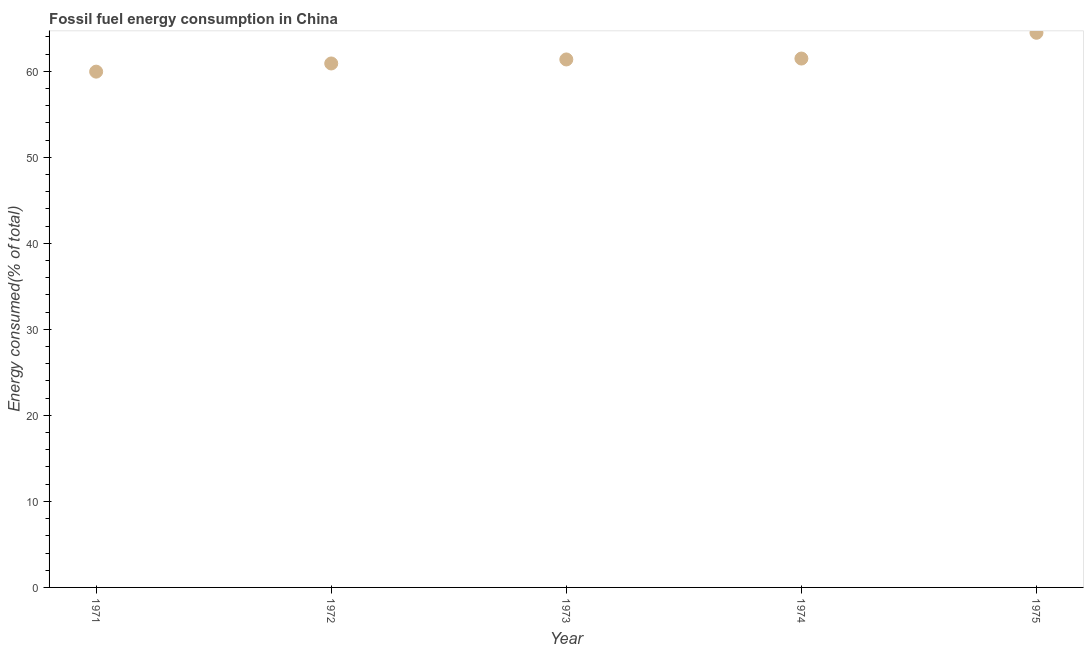What is the fossil fuel energy consumption in 1974?
Ensure brevity in your answer.  61.47. Across all years, what is the maximum fossil fuel energy consumption?
Your answer should be very brief. 64.47. Across all years, what is the minimum fossil fuel energy consumption?
Keep it short and to the point. 59.95. In which year was the fossil fuel energy consumption maximum?
Your answer should be compact. 1975. What is the sum of the fossil fuel energy consumption?
Provide a succinct answer. 308.16. What is the difference between the fossil fuel energy consumption in 1971 and 1973?
Keep it short and to the point. -1.42. What is the average fossil fuel energy consumption per year?
Give a very brief answer. 61.63. What is the median fossil fuel energy consumption?
Provide a short and direct response. 61.37. In how many years, is the fossil fuel energy consumption greater than 26 %?
Provide a short and direct response. 5. What is the ratio of the fossil fuel energy consumption in 1972 to that in 1975?
Give a very brief answer. 0.94. Is the fossil fuel energy consumption in 1971 less than that in 1975?
Make the answer very short. Yes. Is the difference between the fossil fuel energy consumption in 1971 and 1975 greater than the difference between any two years?
Your answer should be compact. Yes. What is the difference between the highest and the second highest fossil fuel energy consumption?
Offer a very short reply. 3. What is the difference between the highest and the lowest fossil fuel energy consumption?
Ensure brevity in your answer.  4.52. In how many years, is the fossil fuel energy consumption greater than the average fossil fuel energy consumption taken over all years?
Your answer should be very brief. 1. Does the fossil fuel energy consumption monotonically increase over the years?
Provide a succinct answer. Yes. How many dotlines are there?
Your response must be concise. 1. What is the title of the graph?
Provide a short and direct response. Fossil fuel energy consumption in China. What is the label or title of the X-axis?
Keep it short and to the point. Year. What is the label or title of the Y-axis?
Your response must be concise. Energy consumed(% of total). What is the Energy consumed(% of total) in 1971?
Offer a very short reply. 59.95. What is the Energy consumed(% of total) in 1972?
Give a very brief answer. 60.9. What is the Energy consumed(% of total) in 1973?
Ensure brevity in your answer.  61.37. What is the Energy consumed(% of total) in 1974?
Provide a short and direct response. 61.47. What is the Energy consumed(% of total) in 1975?
Your answer should be very brief. 64.47. What is the difference between the Energy consumed(% of total) in 1971 and 1972?
Keep it short and to the point. -0.95. What is the difference between the Energy consumed(% of total) in 1971 and 1973?
Your answer should be compact. -1.42. What is the difference between the Energy consumed(% of total) in 1971 and 1974?
Keep it short and to the point. -1.52. What is the difference between the Energy consumed(% of total) in 1971 and 1975?
Your response must be concise. -4.52. What is the difference between the Energy consumed(% of total) in 1972 and 1973?
Make the answer very short. -0.47. What is the difference between the Energy consumed(% of total) in 1972 and 1974?
Offer a terse response. -0.57. What is the difference between the Energy consumed(% of total) in 1972 and 1975?
Your answer should be compact. -3.57. What is the difference between the Energy consumed(% of total) in 1973 and 1974?
Your answer should be very brief. -0.11. What is the difference between the Energy consumed(% of total) in 1973 and 1975?
Provide a short and direct response. -3.1. What is the difference between the Energy consumed(% of total) in 1974 and 1975?
Give a very brief answer. -3. What is the ratio of the Energy consumed(% of total) in 1971 to that in 1974?
Provide a succinct answer. 0.97. What is the ratio of the Energy consumed(% of total) in 1971 to that in 1975?
Offer a very short reply. 0.93. What is the ratio of the Energy consumed(% of total) in 1972 to that in 1973?
Ensure brevity in your answer.  0.99. What is the ratio of the Energy consumed(% of total) in 1972 to that in 1974?
Your answer should be compact. 0.99. What is the ratio of the Energy consumed(% of total) in 1972 to that in 1975?
Ensure brevity in your answer.  0.94. What is the ratio of the Energy consumed(% of total) in 1973 to that in 1974?
Your answer should be very brief. 1. What is the ratio of the Energy consumed(% of total) in 1974 to that in 1975?
Keep it short and to the point. 0.95. 